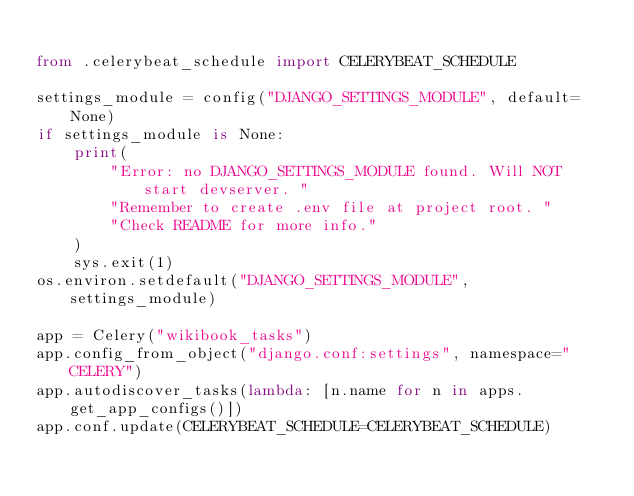<code> <loc_0><loc_0><loc_500><loc_500><_Python_>
from .celerybeat_schedule import CELERYBEAT_SCHEDULE

settings_module = config("DJANGO_SETTINGS_MODULE", default=None)
if settings_module is None:
    print(
        "Error: no DJANGO_SETTINGS_MODULE found. Will NOT start devserver. "
        "Remember to create .env file at project root. "
        "Check README for more info."
    )
    sys.exit(1)
os.environ.setdefault("DJANGO_SETTINGS_MODULE", settings_module)

app = Celery("wikibook_tasks")
app.config_from_object("django.conf:settings", namespace="CELERY")
app.autodiscover_tasks(lambda: [n.name for n in apps.get_app_configs()])
app.conf.update(CELERYBEAT_SCHEDULE=CELERYBEAT_SCHEDULE)
</code> 